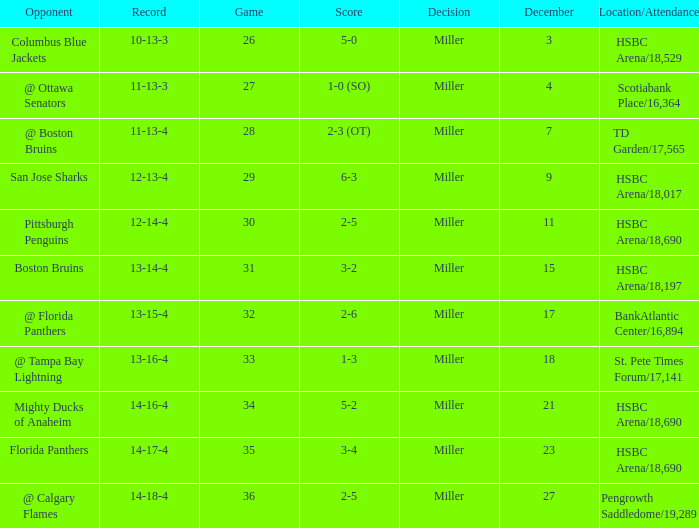Name the opponent for record 10-13-3 Columbus Blue Jackets. 